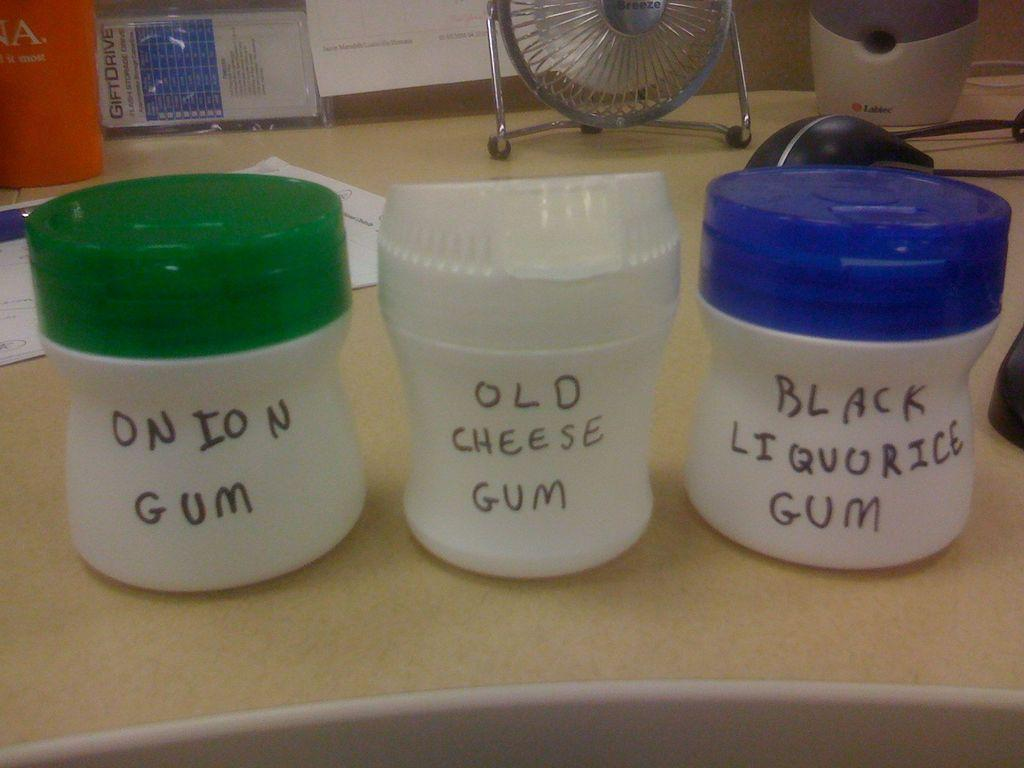<image>
Summarize the visual content of the image. Three white containers with different colored caps and the middle bottle reading Old Cheese Gum. 